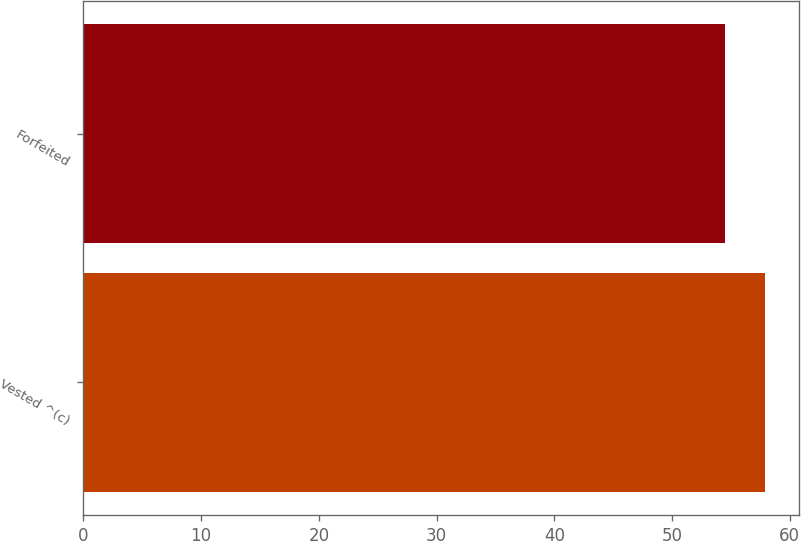Convert chart. <chart><loc_0><loc_0><loc_500><loc_500><bar_chart><fcel>Vested ^(c)<fcel>Forfeited<nl><fcel>57.87<fcel>54.46<nl></chart> 